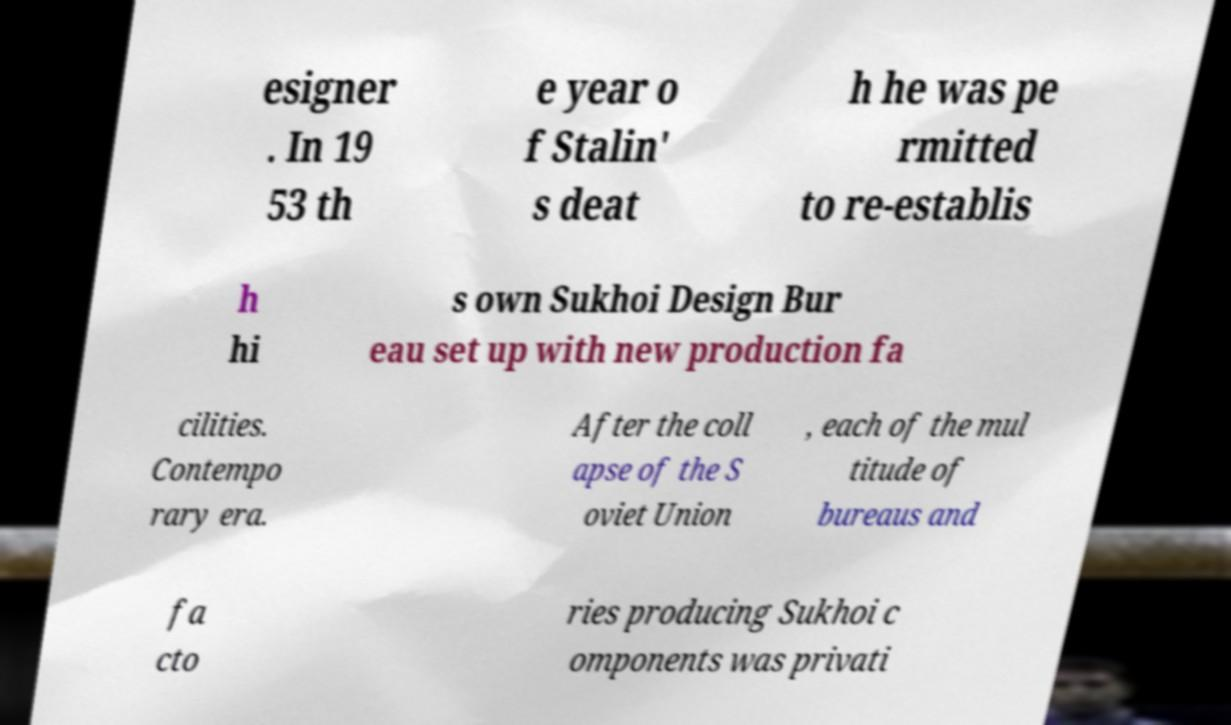Can you read and provide the text displayed in the image?This photo seems to have some interesting text. Can you extract and type it out for me? esigner . In 19 53 th e year o f Stalin' s deat h he was pe rmitted to re-establis h hi s own Sukhoi Design Bur eau set up with new production fa cilities. Contempo rary era. After the coll apse of the S oviet Union , each of the mul titude of bureaus and fa cto ries producing Sukhoi c omponents was privati 